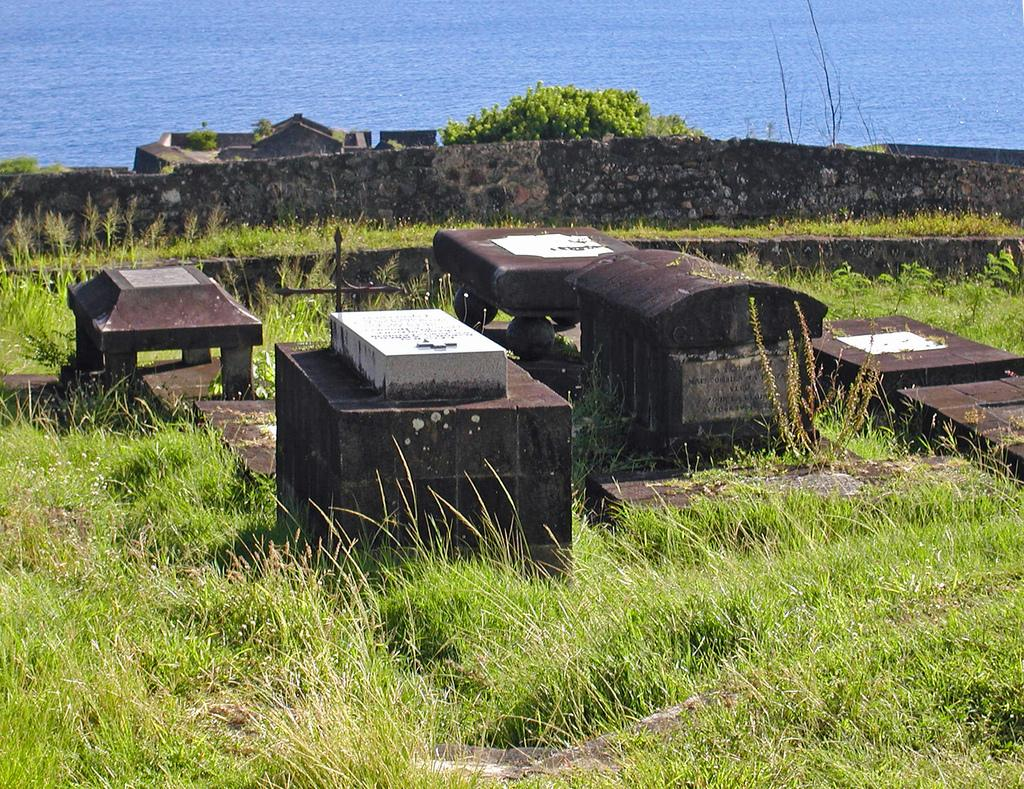What type of terrain is visible in the image? There is a grassland in the image. What objects can be seen on the grassland? There are metal objects on the grassland. What can be seen in the background of the image? There is a wall, trees, and a sea visible in the background of the image. What type of toothbrush can be seen in the image? There is no toothbrush present in the image. What smell is associated with the grassland in the image? The image does not convey any smells, so it is not possible to determine a smell associated with the grassland. 